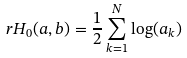<formula> <loc_0><loc_0><loc_500><loc_500>\ r H _ { 0 } ( a , b ) = \frac { 1 } { 2 } \sum _ { k = 1 } ^ { N } \log ( a _ { k } )</formula> 